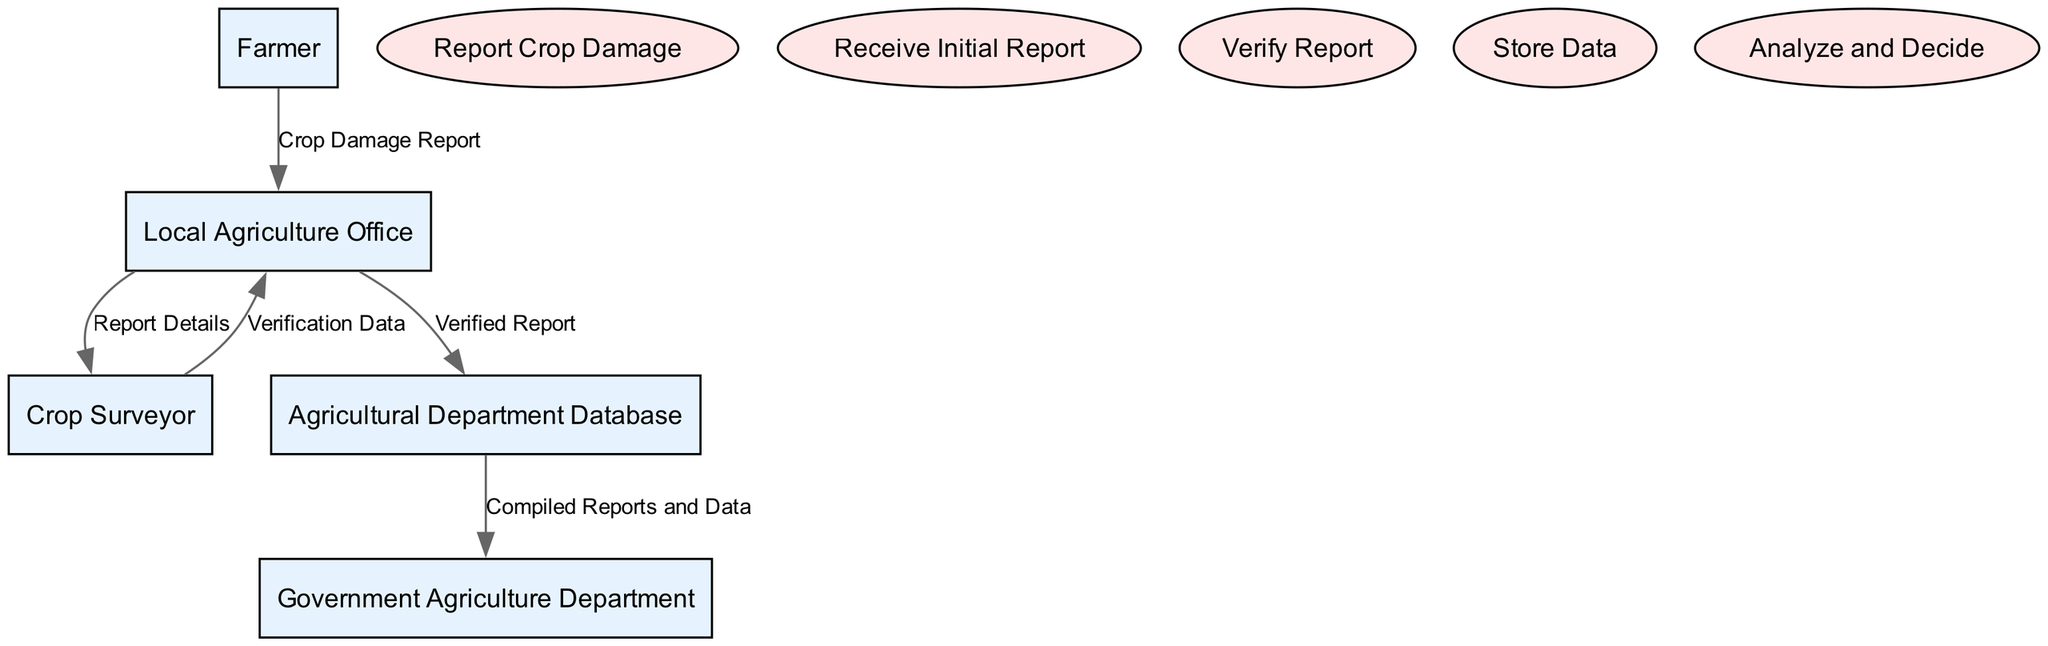What is the first entity involved in the crop damage reporting process? The diagram shows that the first entity in the crop damage reporting process is the Farmer, who initiates the report of crop damage.
Answer: Farmer Which process comes after the "Report Crop Damage"? Analyzing the flow in the diagram, the process that immediately follows "Report Crop Damage" is "Receive Initial Report," which is conducted by the Local Agriculture Office.
Answer: Receive Initial Report How many processes are included in the diagram? By counting the number of listed processes in the diagram, I find there are five distinct processes: Report Crop Damage, Receive Initial Report, Verify Report, Store Data, and Analyze and Decide.
Answer: Five What data flows from the Crop Surveyor to the Local Agriculture Office? The arrow leading from Crop Surveyor to Local Agriculture Office indicates the flow of "Verification Data," which means this is the data that is transferred between these two components.
Answer: Verification Data What is the final authority in the crop damage reporting system? Reviewing the entities, the final authority responsible for analyzing the reports is the Government Agriculture Department, as shown in the data flows directed toward it.
Answer: Government Agriculture Department What type of data does the Local Agriculture Office send to the Agricultural Department Database? The diagram specifies that the Local Agriculture Office sends "Verified Report" data to the Agricultural Department Database for storage.
Answer: Verified Report How many different entities are outlined in the diagram? By examining the diagram, I can identify five different entities: Farmer, Local Agriculture Office, Crop Surveyor, Agricultural Department Database, and Government Agriculture Department.
Answer: Five What process occurs after the verification of the report? Noticing the sequence of processes in the diagram, the process that occurs after verification is "Store Data," where the verified data is stored in the Agricultural Department Database.
Answer: Store Data 